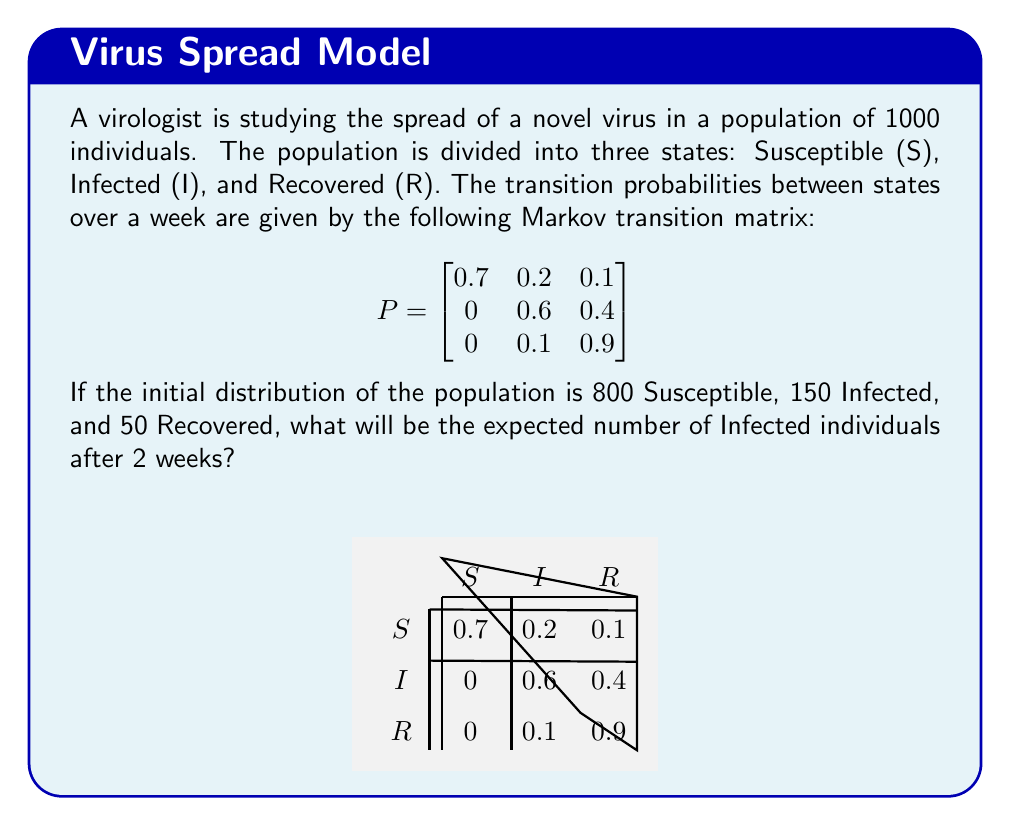Give your solution to this math problem. Let's approach this step-by-step:

1) First, we need to represent the initial distribution as a row vector:

   $v_0 = \begin{bmatrix} 800 & 150 & 50 \end{bmatrix}$

2) To find the distribution after 2 weeks, we need to multiply this vector by the transition matrix twice:

   $v_2 = v_0 \cdot P^2$

3) Let's calculate $P^2$:

   $$P^2 = \begin{bmatrix}
   0.7 & 0.2 & 0.1 \\
   0 & 0.6 & 0.4 \\
   0 & 0.1 & 0.9
   \end{bmatrix} \cdot 
   \begin{bmatrix}
   0.7 & 0.2 & 0.1 \\
   0 & 0.6 & 0.4 \\
   0 & 0.1 & 0.9
   \end{bmatrix}$$

   $$P^2 = \begin{bmatrix}
   0.49 & 0.26 & 0.25 \\
   0 & 0.42 & 0.58 \\
   0 & 0.15 & 0.85
   \end{bmatrix}$$

4) Now, let's multiply $v_0$ by $P^2$:

   $v_2 = \begin{bmatrix} 800 & 150 & 50 \end{bmatrix} \cdot 
   \begin{bmatrix}
   0.49 & 0.26 & 0.25 \\
   0 & 0.42 & 0.58 \\
   0 & 0.15 & 0.85
   \end{bmatrix}$

5) Performing the matrix multiplication:

   $v_2 = \begin{bmatrix} 392 & 250.5 & 357.5 \end{bmatrix}$

6) The second element of this vector represents the expected number of Infected individuals after 2 weeks.

Therefore, the expected number of Infected individuals after 2 weeks is 250.5, which rounds to 251 people.
Answer: 251 